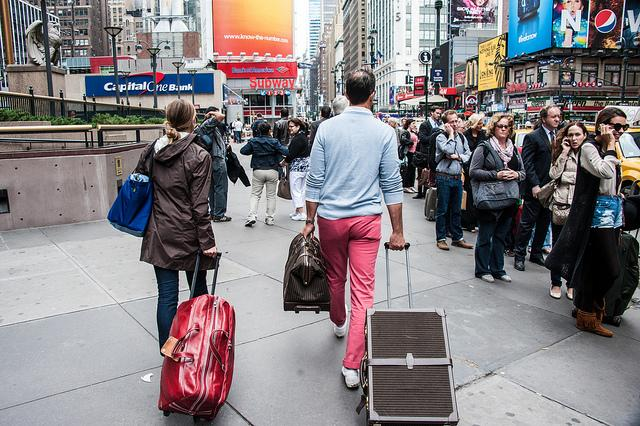The Red white and blue circular emblem on the visible billboard here advertises for what company? pepsi 